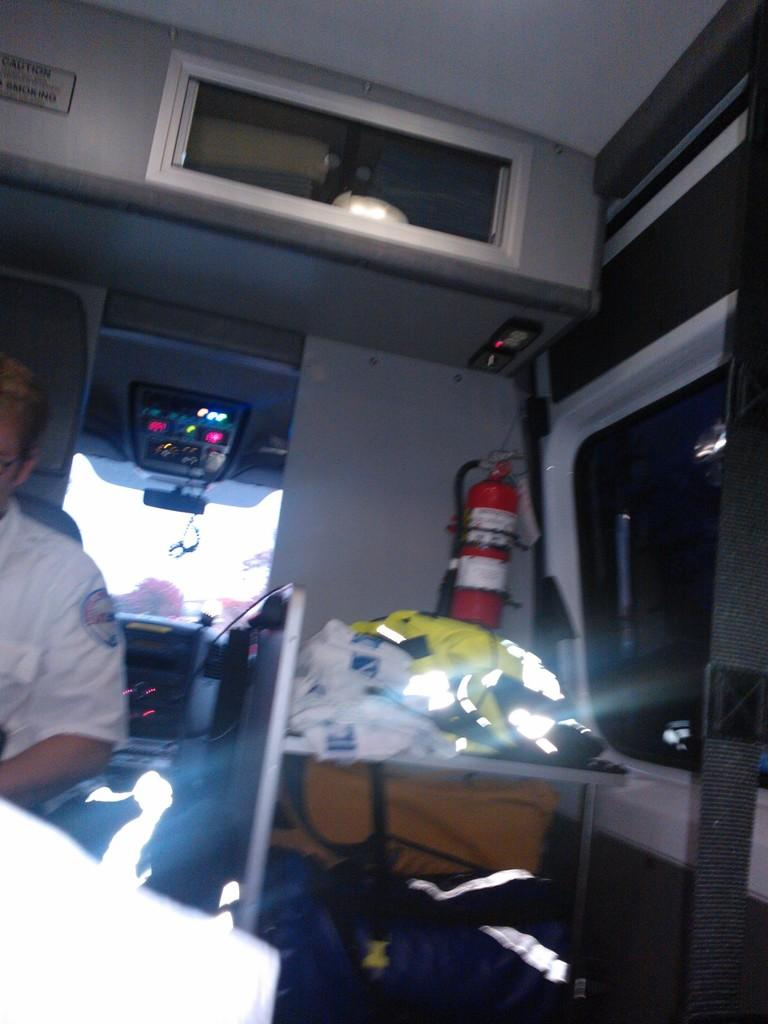Who or what is present in the image? There is a person in the image. What safety device can be seen in the image? There is a fire extinguisher in the image. What piece of furniture is visible in the image? There is a table with objects on it in the image. What else can be seen on the floor in the image? There are objects on the floor in the image. What type of egg is being used by the writer in the image? There is no writer or egg present in the image. 